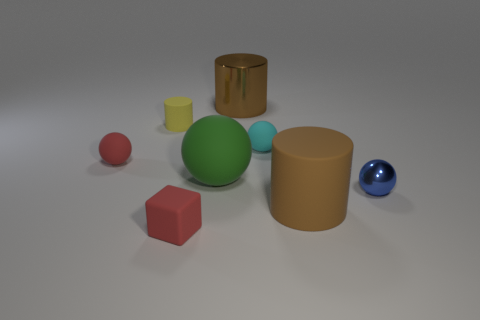There is a tiny ball to the left of the small red rubber cube; is it the same color as the tiny thing in front of the blue shiny sphere?
Your answer should be compact. Yes. There is a cylinder in front of the tiny blue object; does it have the same color as the shiny cylinder?
Provide a short and direct response. Yes. Do the brown matte object and the brown cylinder that is behind the small yellow thing have the same size?
Give a very brief answer. Yes. Are there any other blue metallic objects of the same size as the blue object?
Your answer should be very brief. No. What number of other things are made of the same material as the small red ball?
Provide a short and direct response. 5. There is a tiny rubber object that is both in front of the cyan matte ball and behind the small block; what color is it?
Offer a terse response. Red. Are the object that is on the right side of the large brown rubber thing and the ball left of the yellow rubber thing made of the same material?
Offer a very short reply. No. There is a cyan rubber ball that is behind the blue metal sphere; is its size the same as the metallic ball?
Make the answer very short. Yes. Does the block have the same color as the object that is left of the yellow rubber thing?
Offer a terse response. Yes. There is a rubber thing that is the same color as the big metallic cylinder; what is its shape?
Offer a very short reply. Cylinder. 